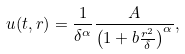<formula> <loc_0><loc_0><loc_500><loc_500>u ( t , r ) = \frac { 1 } { \delta ^ { \alpha } } \frac { A } { \left ( 1 + b \frac { r ^ { 2 } } { \delta } \right ) ^ { \alpha } } ,</formula> 